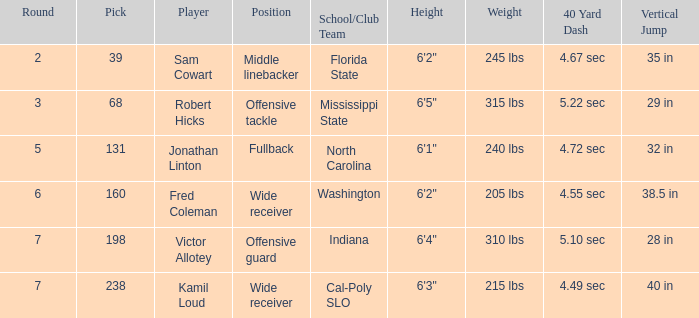Which School/Club Team has a Pick of 198? Indiana. 